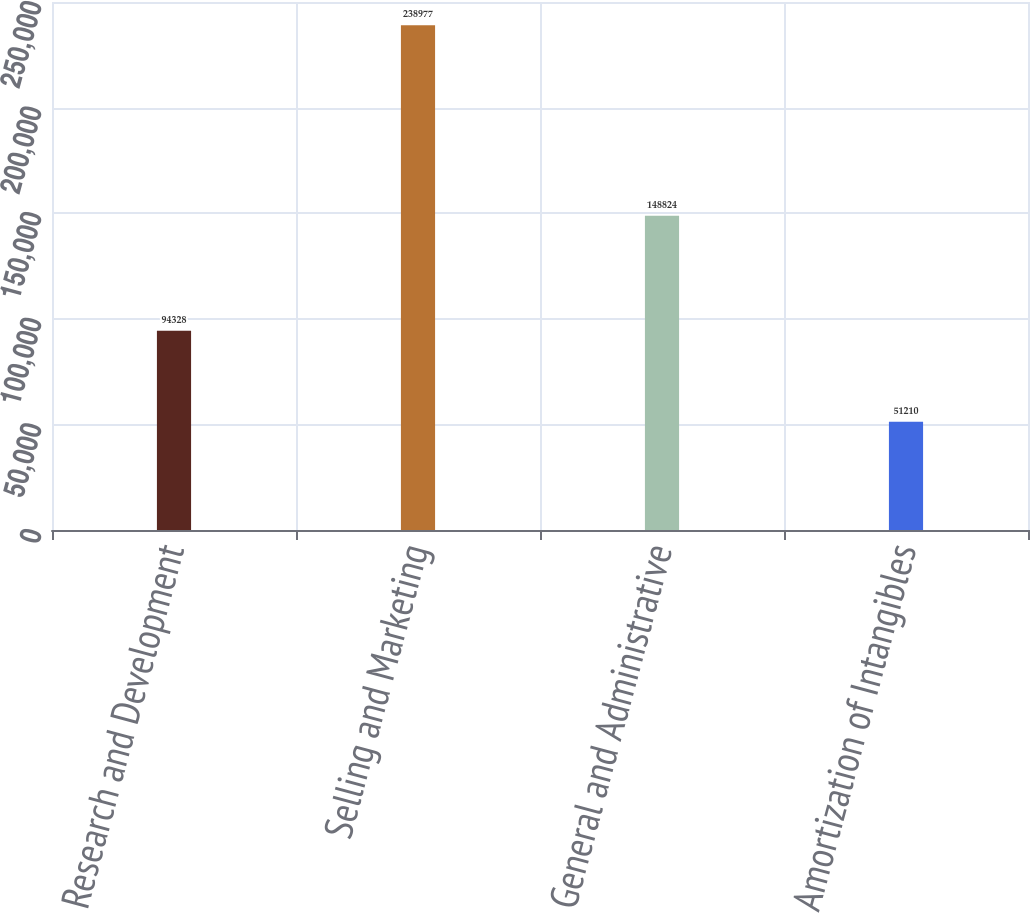Convert chart. <chart><loc_0><loc_0><loc_500><loc_500><bar_chart><fcel>Research and Development<fcel>Selling and Marketing<fcel>General and Administrative<fcel>Amortization of Intangibles<nl><fcel>94328<fcel>238977<fcel>148824<fcel>51210<nl></chart> 